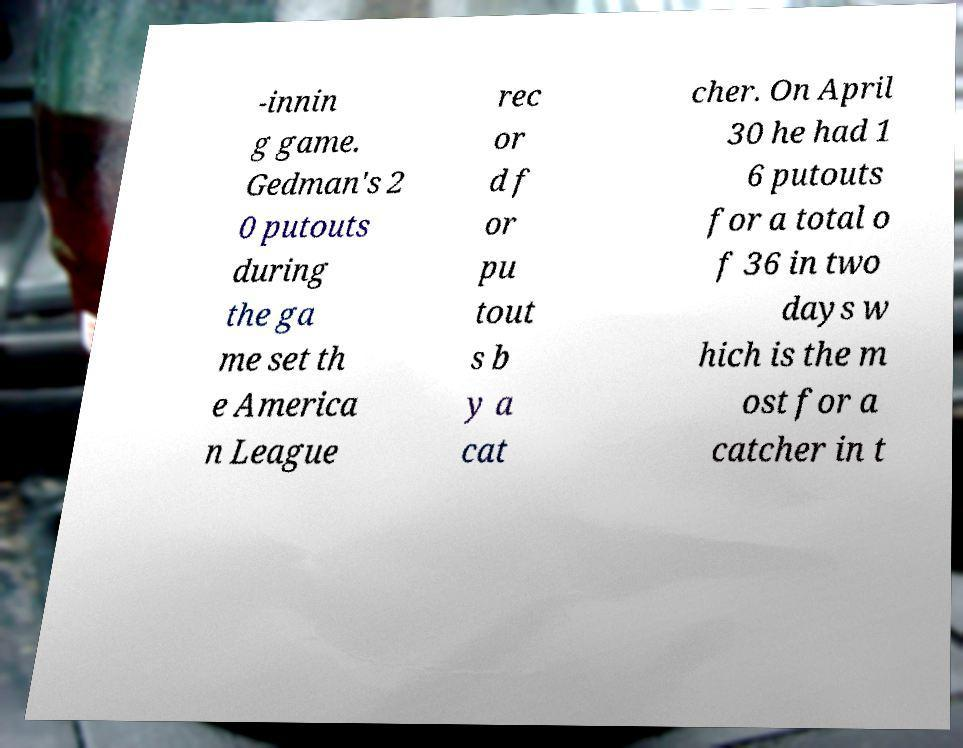Could you extract and type out the text from this image? -innin g game. Gedman's 2 0 putouts during the ga me set th e America n League rec or d f or pu tout s b y a cat cher. On April 30 he had 1 6 putouts for a total o f 36 in two days w hich is the m ost for a catcher in t 